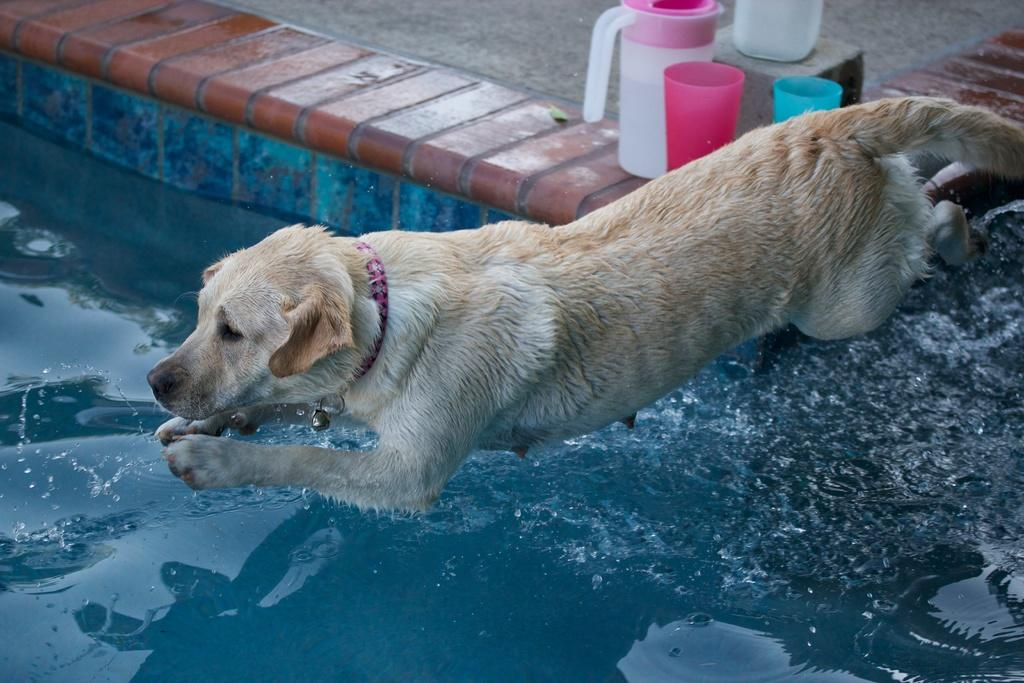What is at the bottom of the image? There is water at the bottom of the image. What can be seen in the middle of the image? There is a dog in the middle of the image. What objects are in the background of the image? There are two plastic glasses and a plastic jug in the background of the image. What type of letters can be seen on the dog's collar in the image? There is no dog collar visible in the image, and therefore no letters can be seen on it. Is there a tent in the background of the image? No, there is no tent present in the image. 